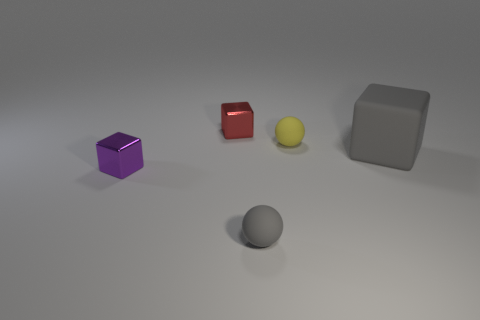What materials are the objects in the image made of? The objects present in the image seem to possess distinct textures indicating various materials: the purple and grey cubes appear to be made of a metallic substance, the red cube looks like it's made of glossy plastic, and the sphere has a matte finish that could suggest a rubber or matte-painted material.  Can you describe the lighting in the scene? The lighting in the image casts soft shadows and suggests a diffused light source, likely from above. It creates a calm and even illumination on the objects, with no harsh highlights, enriching the composition by giving a gentle depth to the scene. 